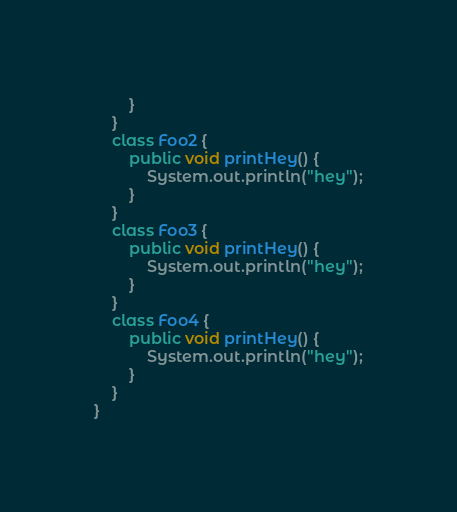Convert code to text. <code><loc_0><loc_0><loc_500><loc_500><_Java_>        }
    }
    class Foo2 {
        public void printHey() {
            System.out.println("hey");
        }
    }
    class Foo3 {
        public void printHey() {
            System.out.println("hey");
        }
    }
    class Foo4 {
        public void printHey() {
            System.out.println("hey");
        }
    }
}
</code> 